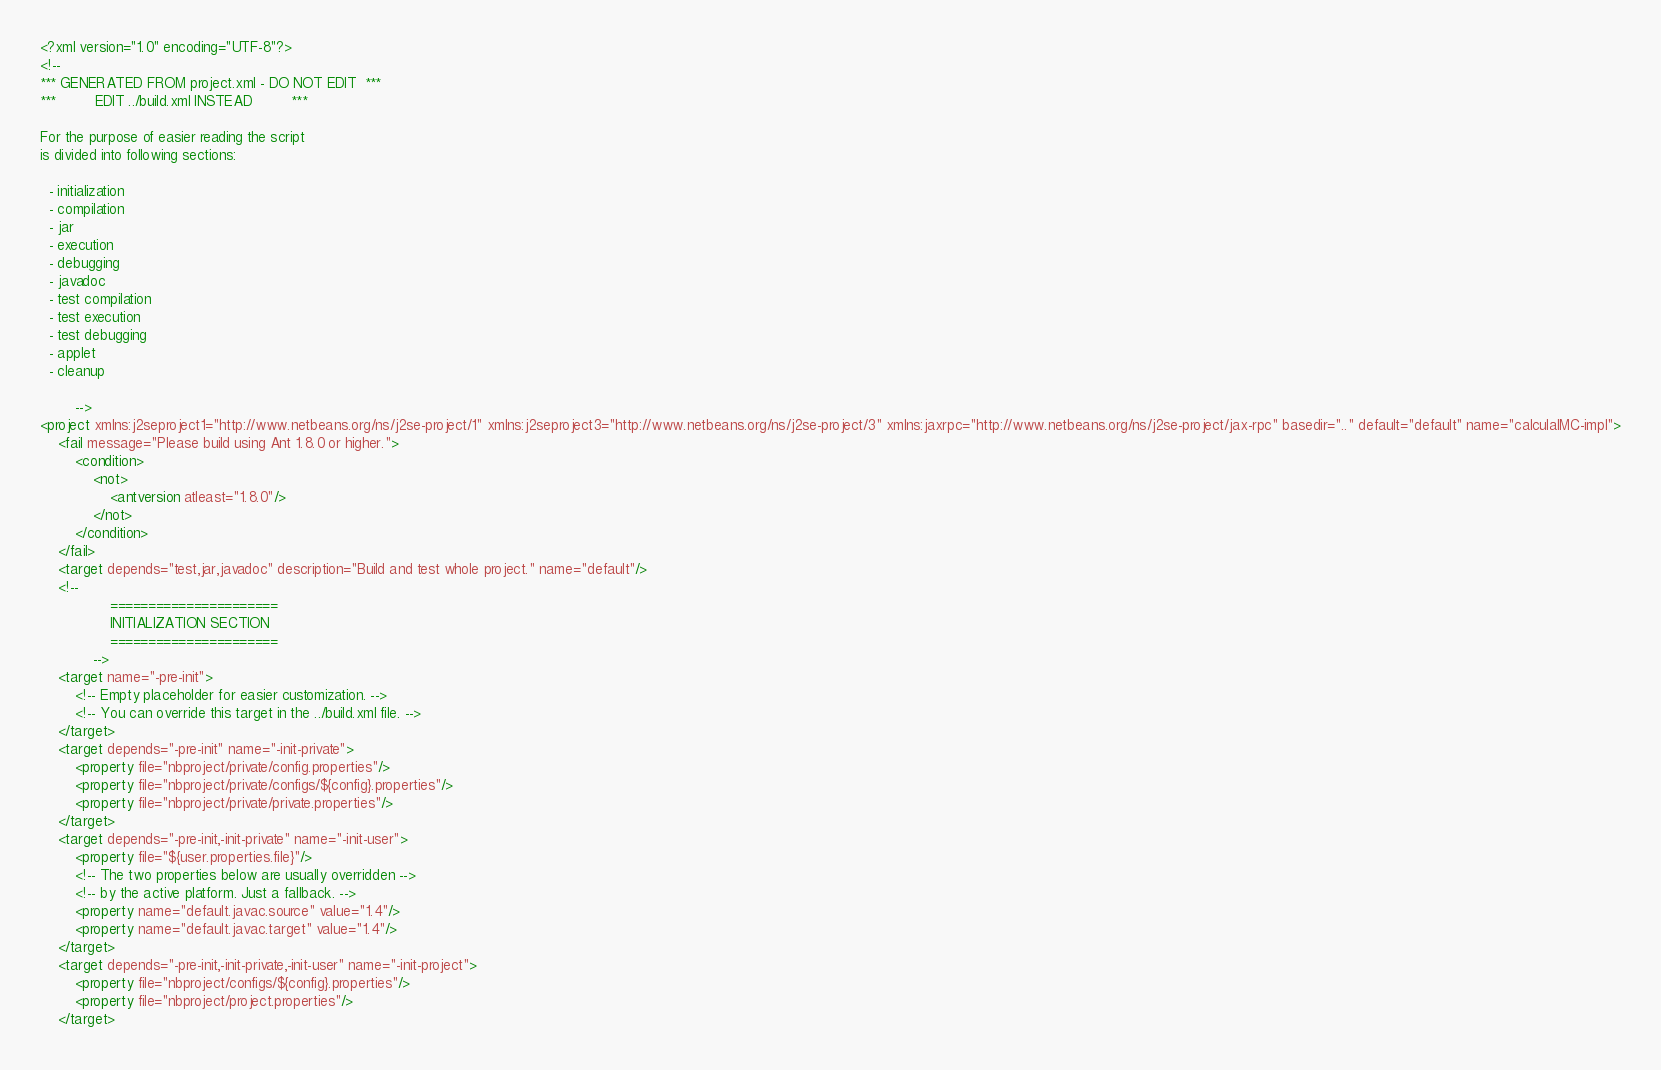Convert code to text. <code><loc_0><loc_0><loc_500><loc_500><_XML_><?xml version="1.0" encoding="UTF-8"?>
<!--
*** GENERATED FROM project.xml - DO NOT EDIT  ***
***         EDIT ../build.xml INSTEAD         ***

For the purpose of easier reading the script
is divided into following sections:

  - initialization
  - compilation
  - jar
  - execution
  - debugging
  - javadoc
  - test compilation
  - test execution
  - test debugging
  - applet
  - cleanup

        -->
<project xmlns:j2seproject1="http://www.netbeans.org/ns/j2se-project/1" xmlns:j2seproject3="http://www.netbeans.org/ns/j2se-project/3" xmlns:jaxrpc="http://www.netbeans.org/ns/j2se-project/jax-rpc" basedir=".." default="default" name="calculaIMC-impl">
    <fail message="Please build using Ant 1.8.0 or higher.">
        <condition>
            <not>
                <antversion atleast="1.8.0"/>
            </not>
        </condition>
    </fail>
    <target depends="test,jar,javadoc" description="Build and test whole project." name="default"/>
    <!-- 
                ======================
                INITIALIZATION SECTION 
                ======================
            -->
    <target name="-pre-init">
        <!-- Empty placeholder for easier customization. -->
        <!-- You can override this target in the ../build.xml file. -->
    </target>
    <target depends="-pre-init" name="-init-private">
        <property file="nbproject/private/config.properties"/>
        <property file="nbproject/private/configs/${config}.properties"/>
        <property file="nbproject/private/private.properties"/>
    </target>
    <target depends="-pre-init,-init-private" name="-init-user">
        <property file="${user.properties.file}"/>
        <!-- The two properties below are usually overridden -->
        <!-- by the active platform. Just a fallback. -->
        <property name="default.javac.source" value="1.4"/>
        <property name="default.javac.target" value="1.4"/>
    </target>
    <target depends="-pre-init,-init-private,-init-user" name="-init-project">
        <property file="nbproject/configs/${config}.properties"/>
        <property file="nbproject/project.properties"/>
    </target></code> 